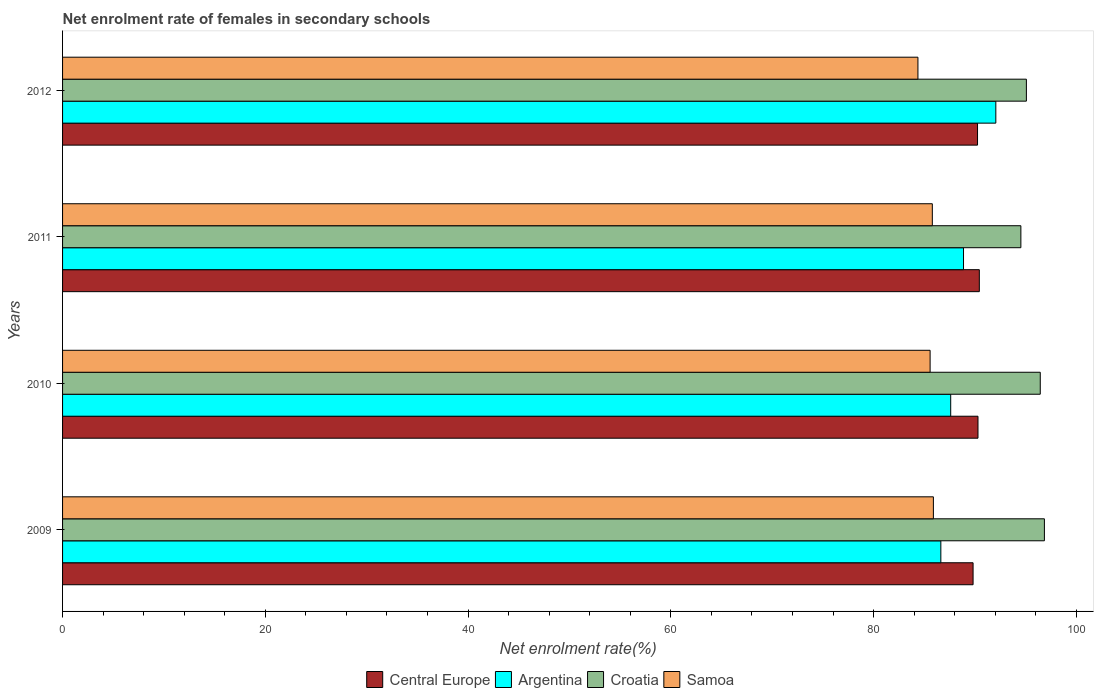How many different coloured bars are there?
Make the answer very short. 4. Are the number of bars per tick equal to the number of legend labels?
Keep it short and to the point. Yes. Are the number of bars on each tick of the Y-axis equal?
Offer a terse response. Yes. How many bars are there on the 2nd tick from the bottom?
Make the answer very short. 4. What is the label of the 1st group of bars from the top?
Keep it short and to the point. 2012. In how many cases, is the number of bars for a given year not equal to the number of legend labels?
Provide a succinct answer. 0. What is the net enrolment rate of females in secondary schools in Samoa in 2010?
Your answer should be compact. 85.58. Across all years, what is the maximum net enrolment rate of females in secondary schools in Argentina?
Make the answer very short. 92.06. Across all years, what is the minimum net enrolment rate of females in secondary schools in Central Europe?
Ensure brevity in your answer.  89.82. In which year was the net enrolment rate of females in secondary schools in Argentina maximum?
Offer a terse response. 2012. In which year was the net enrolment rate of females in secondary schools in Central Europe minimum?
Make the answer very short. 2009. What is the total net enrolment rate of females in secondary schools in Croatia in the graph?
Keep it short and to the point. 382.9. What is the difference between the net enrolment rate of females in secondary schools in Samoa in 2009 and that in 2011?
Provide a short and direct response. 0.11. What is the difference between the net enrolment rate of females in secondary schools in Samoa in 2010 and the net enrolment rate of females in secondary schools in Argentina in 2009?
Offer a very short reply. -1.06. What is the average net enrolment rate of females in secondary schools in Central Europe per year?
Your answer should be compact. 90.2. In the year 2011, what is the difference between the net enrolment rate of females in secondary schools in Samoa and net enrolment rate of females in secondary schools in Central Europe?
Provide a short and direct response. -4.64. In how many years, is the net enrolment rate of females in secondary schools in Samoa greater than 32 %?
Your answer should be compact. 4. What is the ratio of the net enrolment rate of females in secondary schools in Samoa in 2011 to that in 2012?
Your response must be concise. 1.02. Is the net enrolment rate of females in secondary schools in Central Europe in 2009 less than that in 2012?
Offer a very short reply. Yes. What is the difference between the highest and the second highest net enrolment rate of females in secondary schools in Croatia?
Make the answer very short. 0.41. What is the difference between the highest and the lowest net enrolment rate of females in secondary schools in Central Europe?
Your answer should be compact. 0.62. In how many years, is the net enrolment rate of females in secondary schools in Samoa greater than the average net enrolment rate of females in secondary schools in Samoa taken over all years?
Make the answer very short. 3. Is the sum of the net enrolment rate of females in secondary schools in Samoa in 2009 and 2012 greater than the maximum net enrolment rate of females in secondary schools in Croatia across all years?
Ensure brevity in your answer.  Yes. Is it the case that in every year, the sum of the net enrolment rate of females in secondary schools in Argentina and net enrolment rate of females in secondary schools in Central Europe is greater than the sum of net enrolment rate of females in secondary schools in Samoa and net enrolment rate of females in secondary schools in Croatia?
Your answer should be compact. No. What does the 1st bar from the top in 2012 represents?
Keep it short and to the point. Samoa. What does the 1st bar from the bottom in 2012 represents?
Your answer should be compact. Central Europe. Is it the case that in every year, the sum of the net enrolment rate of females in secondary schools in Croatia and net enrolment rate of females in secondary schools in Central Europe is greater than the net enrolment rate of females in secondary schools in Argentina?
Your response must be concise. Yes. How many years are there in the graph?
Make the answer very short. 4. What is the difference between two consecutive major ticks on the X-axis?
Your answer should be very brief. 20. Does the graph contain any zero values?
Make the answer very short. No. How many legend labels are there?
Your response must be concise. 4. How are the legend labels stacked?
Provide a short and direct response. Horizontal. What is the title of the graph?
Your response must be concise. Net enrolment rate of females in secondary schools. What is the label or title of the X-axis?
Your answer should be compact. Net enrolment rate(%). What is the label or title of the Y-axis?
Your answer should be compact. Years. What is the Net enrolment rate(%) in Central Europe in 2009?
Your answer should be compact. 89.82. What is the Net enrolment rate(%) in Argentina in 2009?
Provide a succinct answer. 86.64. What is the Net enrolment rate(%) of Croatia in 2009?
Provide a succinct answer. 96.85. What is the Net enrolment rate(%) of Samoa in 2009?
Keep it short and to the point. 85.9. What is the Net enrolment rate(%) of Central Europe in 2010?
Your answer should be very brief. 90.3. What is the Net enrolment rate(%) of Argentina in 2010?
Your response must be concise. 87.61. What is the Net enrolment rate(%) of Croatia in 2010?
Your answer should be very brief. 96.44. What is the Net enrolment rate(%) of Samoa in 2010?
Offer a terse response. 85.58. What is the Net enrolment rate(%) of Central Europe in 2011?
Your response must be concise. 90.43. What is the Net enrolment rate(%) of Argentina in 2011?
Your answer should be compact. 88.87. What is the Net enrolment rate(%) of Croatia in 2011?
Provide a succinct answer. 94.53. What is the Net enrolment rate(%) in Samoa in 2011?
Give a very brief answer. 85.8. What is the Net enrolment rate(%) in Central Europe in 2012?
Your answer should be very brief. 90.26. What is the Net enrolment rate(%) in Argentina in 2012?
Provide a short and direct response. 92.06. What is the Net enrolment rate(%) of Croatia in 2012?
Offer a terse response. 95.08. What is the Net enrolment rate(%) in Samoa in 2012?
Ensure brevity in your answer.  84.38. Across all years, what is the maximum Net enrolment rate(%) of Central Europe?
Your answer should be very brief. 90.43. Across all years, what is the maximum Net enrolment rate(%) of Argentina?
Keep it short and to the point. 92.06. Across all years, what is the maximum Net enrolment rate(%) of Croatia?
Provide a succinct answer. 96.85. Across all years, what is the maximum Net enrolment rate(%) in Samoa?
Provide a short and direct response. 85.9. Across all years, what is the minimum Net enrolment rate(%) of Central Europe?
Provide a short and direct response. 89.82. Across all years, what is the minimum Net enrolment rate(%) of Argentina?
Offer a terse response. 86.64. Across all years, what is the minimum Net enrolment rate(%) of Croatia?
Your answer should be very brief. 94.53. Across all years, what is the minimum Net enrolment rate(%) of Samoa?
Provide a short and direct response. 84.38. What is the total Net enrolment rate(%) of Central Europe in the graph?
Ensure brevity in your answer.  360.81. What is the total Net enrolment rate(%) in Argentina in the graph?
Offer a terse response. 355.18. What is the total Net enrolment rate(%) of Croatia in the graph?
Provide a short and direct response. 382.9. What is the total Net enrolment rate(%) in Samoa in the graph?
Provide a short and direct response. 341.65. What is the difference between the Net enrolment rate(%) of Central Europe in 2009 and that in 2010?
Keep it short and to the point. -0.48. What is the difference between the Net enrolment rate(%) in Argentina in 2009 and that in 2010?
Ensure brevity in your answer.  -0.97. What is the difference between the Net enrolment rate(%) in Croatia in 2009 and that in 2010?
Provide a short and direct response. 0.41. What is the difference between the Net enrolment rate(%) of Samoa in 2009 and that in 2010?
Your response must be concise. 0.32. What is the difference between the Net enrolment rate(%) of Central Europe in 2009 and that in 2011?
Give a very brief answer. -0.62. What is the difference between the Net enrolment rate(%) of Argentina in 2009 and that in 2011?
Provide a short and direct response. -2.24. What is the difference between the Net enrolment rate(%) in Croatia in 2009 and that in 2011?
Your answer should be very brief. 2.32. What is the difference between the Net enrolment rate(%) of Samoa in 2009 and that in 2011?
Offer a very short reply. 0.11. What is the difference between the Net enrolment rate(%) in Central Europe in 2009 and that in 2012?
Your response must be concise. -0.44. What is the difference between the Net enrolment rate(%) of Argentina in 2009 and that in 2012?
Your answer should be very brief. -5.42. What is the difference between the Net enrolment rate(%) of Croatia in 2009 and that in 2012?
Provide a succinct answer. 1.78. What is the difference between the Net enrolment rate(%) of Samoa in 2009 and that in 2012?
Give a very brief answer. 1.52. What is the difference between the Net enrolment rate(%) of Central Europe in 2010 and that in 2011?
Offer a terse response. -0.13. What is the difference between the Net enrolment rate(%) in Argentina in 2010 and that in 2011?
Offer a terse response. -1.26. What is the difference between the Net enrolment rate(%) of Croatia in 2010 and that in 2011?
Ensure brevity in your answer.  1.91. What is the difference between the Net enrolment rate(%) of Samoa in 2010 and that in 2011?
Provide a short and direct response. -0.22. What is the difference between the Net enrolment rate(%) of Central Europe in 2010 and that in 2012?
Give a very brief answer. 0.04. What is the difference between the Net enrolment rate(%) of Argentina in 2010 and that in 2012?
Ensure brevity in your answer.  -4.45. What is the difference between the Net enrolment rate(%) in Croatia in 2010 and that in 2012?
Give a very brief answer. 1.37. What is the difference between the Net enrolment rate(%) of Samoa in 2010 and that in 2012?
Offer a very short reply. 1.2. What is the difference between the Net enrolment rate(%) in Central Europe in 2011 and that in 2012?
Keep it short and to the point. 0.18. What is the difference between the Net enrolment rate(%) of Argentina in 2011 and that in 2012?
Provide a short and direct response. -3.19. What is the difference between the Net enrolment rate(%) in Croatia in 2011 and that in 2012?
Keep it short and to the point. -0.54. What is the difference between the Net enrolment rate(%) in Samoa in 2011 and that in 2012?
Offer a very short reply. 1.42. What is the difference between the Net enrolment rate(%) in Central Europe in 2009 and the Net enrolment rate(%) in Argentina in 2010?
Provide a short and direct response. 2.21. What is the difference between the Net enrolment rate(%) of Central Europe in 2009 and the Net enrolment rate(%) of Croatia in 2010?
Your response must be concise. -6.63. What is the difference between the Net enrolment rate(%) in Central Europe in 2009 and the Net enrolment rate(%) in Samoa in 2010?
Provide a short and direct response. 4.24. What is the difference between the Net enrolment rate(%) in Argentina in 2009 and the Net enrolment rate(%) in Croatia in 2010?
Your answer should be very brief. -9.81. What is the difference between the Net enrolment rate(%) of Argentina in 2009 and the Net enrolment rate(%) of Samoa in 2010?
Your answer should be compact. 1.06. What is the difference between the Net enrolment rate(%) in Croatia in 2009 and the Net enrolment rate(%) in Samoa in 2010?
Your response must be concise. 11.27. What is the difference between the Net enrolment rate(%) in Central Europe in 2009 and the Net enrolment rate(%) in Argentina in 2011?
Your response must be concise. 0.94. What is the difference between the Net enrolment rate(%) in Central Europe in 2009 and the Net enrolment rate(%) in Croatia in 2011?
Your response must be concise. -4.71. What is the difference between the Net enrolment rate(%) of Central Europe in 2009 and the Net enrolment rate(%) of Samoa in 2011?
Offer a very short reply. 4.02. What is the difference between the Net enrolment rate(%) in Argentina in 2009 and the Net enrolment rate(%) in Croatia in 2011?
Offer a terse response. -7.9. What is the difference between the Net enrolment rate(%) in Argentina in 2009 and the Net enrolment rate(%) in Samoa in 2011?
Offer a very short reply. 0.84. What is the difference between the Net enrolment rate(%) in Croatia in 2009 and the Net enrolment rate(%) in Samoa in 2011?
Provide a succinct answer. 11.05. What is the difference between the Net enrolment rate(%) of Central Europe in 2009 and the Net enrolment rate(%) of Argentina in 2012?
Keep it short and to the point. -2.24. What is the difference between the Net enrolment rate(%) in Central Europe in 2009 and the Net enrolment rate(%) in Croatia in 2012?
Give a very brief answer. -5.26. What is the difference between the Net enrolment rate(%) in Central Europe in 2009 and the Net enrolment rate(%) in Samoa in 2012?
Ensure brevity in your answer.  5.44. What is the difference between the Net enrolment rate(%) in Argentina in 2009 and the Net enrolment rate(%) in Croatia in 2012?
Provide a succinct answer. -8.44. What is the difference between the Net enrolment rate(%) of Argentina in 2009 and the Net enrolment rate(%) of Samoa in 2012?
Offer a very short reply. 2.26. What is the difference between the Net enrolment rate(%) of Croatia in 2009 and the Net enrolment rate(%) of Samoa in 2012?
Ensure brevity in your answer.  12.47. What is the difference between the Net enrolment rate(%) in Central Europe in 2010 and the Net enrolment rate(%) in Argentina in 2011?
Ensure brevity in your answer.  1.43. What is the difference between the Net enrolment rate(%) in Central Europe in 2010 and the Net enrolment rate(%) in Croatia in 2011?
Make the answer very short. -4.23. What is the difference between the Net enrolment rate(%) in Central Europe in 2010 and the Net enrolment rate(%) in Samoa in 2011?
Your response must be concise. 4.5. What is the difference between the Net enrolment rate(%) of Argentina in 2010 and the Net enrolment rate(%) of Croatia in 2011?
Your response must be concise. -6.92. What is the difference between the Net enrolment rate(%) of Argentina in 2010 and the Net enrolment rate(%) of Samoa in 2011?
Keep it short and to the point. 1.81. What is the difference between the Net enrolment rate(%) of Croatia in 2010 and the Net enrolment rate(%) of Samoa in 2011?
Give a very brief answer. 10.65. What is the difference between the Net enrolment rate(%) of Central Europe in 2010 and the Net enrolment rate(%) of Argentina in 2012?
Offer a terse response. -1.76. What is the difference between the Net enrolment rate(%) of Central Europe in 2010 and the Net enrolment rate(%) of Croatia in 2012?
Your answer should be very brief. -4.78. What is the difference between the Net enrolment rate(%) in Central Europe in 2010 and the Net enrolment rate(%) in Samoa in 2012?
Your answer should be compact. 5.92. What is the difference between the Net enrolment rate(%) of Argentina in 2010 and the Net enrolment rate(%) of Croatia in 2012?
Ensure brevity in your answer.  -7.47. What is the difference between the Net enrolment rate(%) in Argentina in 2010 and the Net enrolment rate(%) in Samoa in 2012?
Give a very brief answer. 3.23. What is the difference between the Net enrolment rate(%) of Croatia in 2010 and the Net enrolment rate(%) of Samoa in 2012?
Give a very brief answer. 12.07. What is the difference between the Net enrolment rate(%) in Central Europe in 2011 and the Net enrolment rate(%) in Argentina in 2012?
Your answer should be very brief. -1.63. What is the difference between the Net enrolment rate(%) in Central Europe in 2011 and the Net enrolment rate(%) in Croatia in 2012?
Make the answer very short. -4.64. What is the difference between the Net enrolment rate(%) in Central Europe in 2011 and the Net enrolment rate(%) in Samoa in 2012?
Provide a succinct answer. 6.06. What is the difference between the Net enrolment rate(%) in Argentina in 2011 and the Net enrolment rate(%) in Croatia in 2012?
Provide a short and direct response. -6.2. What is the difference between the Net enrolment rate(%) in Argentina in 2011 and the Net enrolment rate(%) in Samoa in 2012?
Give a very brief answer. 4.5. What is the difference between the Net enrolment rate(%) in Croatia in 2011 and the Net enrolment rate(%) in Samoa in 2012?
Offer a terse response. 10.15. What is the average Net enrolment rate(%) in Central Europe per year?
Keep it short and to the point. 90.2. What is the average Net enrolment rate(%) in Argentina per year?
Ensure brevity in your answer.  88.79. What is the average Net enrolment rate(%) in Croatia per year?
Provide a short and direct response. 95.73. What is the average Net enrolment rate(%) of Samoa per year?
Offer a very short reply. 85.41. In the year 2009, what is the difference between the Net enrolment rate(%) in Central Europe and Net enrolment rate(%) in Argentina?
Provide a short and direct response. 3.18. In the year 2009, what is the difference between the Net enrolment rate(%) in Central Europe and Net enrolment rate(%) in Croatia?
Your answer should be compact. -7.03. In the year 2009, what is the difference between the Net enrolment rate(%) in Central Europe and Net enrolment rate(%) in Samoa?
Make the answer very short. 3.92. In the year 2009, what is the difference between the Net enrolment rate(%) in Argentina and Net enrolment rate(%) in Croatia?
Provide a short and direct response. -10.22. In the year 2009, what is the difference between the Net enrolment rate(%) in Argentina and Net enrolment rate(%) in Samoa?
Make the answer very short. 0.73. In the year 2009, what is the difference between the Net enrolment rate(%) of Croatia and Net enrolment rate(%) of Samoa?
Give a very brief answer. 10.95. In the year 2010, what is the difference between the Net enrolment rate(%) in Central Europe and Net enrolment rate(%) in Argentina?
Provide a short and direct response. 2.69. In the year 2010, what is the difference between the Net enrolment rate(%) of Central Europe and Net enrolment rate(%) of Croatia?
Give a very brief answer. -6.14. In the year 2010, what is the difference between the Net enrolment rate(%) in Central Europe and Net enrolment rate(%) in Samoa?
Provide a short and direct response. 4.72. In the year 2010, what is the difference between the Net enrolment rate(%) of Argentina and Net enrolment rate(%) of Croatia?
Provide a succinct answer. -8.84. In the year 2010, what is the difference between the Net enrolment rate(%) in Argentina and Net enrolment rate(%) in Samoa?
Ensure brevity in your answer.  2.03. In the year 2010, what is the difference between the Net enrolment rate(%) of Croatia and Net enrolment rate(%) of Samoa?
Give a very brief answer. 10.87. In the year 2011, what is the difference between the Net enrolment rate(%) in Central Europe and Net enrolment rate(%) in Argentina?
Your answer should be compact. 1.56. In the year 2011, what is the difference between the Net enrolment rate(%) in Central Europe and Net enrolment rate(%) in Croatia?
Offer a terse response. -4.1. In the year 2011, what is the difference between the Net enrolment rate(%) of Central Europe and Net enrolment rate(%) of Samoa?
Your response must be concise. 4.64. In the year 2011, what is the difference between the Net enrolment rate(%) in Argentina and Net enrolment rate(%) in Croatia?
Provide a succinct answer. -5.66. In the year 2011, what is the difference between the Net enrolment rate(%) in Argentina and Net enrolment rate(%) in Samoa?
Ensure brevity in your answer.  3.08. In the year 2011, what is the difference between the Net enrolment rate(%) of Croatia and Net enrolment rate(%) of Samoa?
Offer a very short reply. 8.73. In the year 2012, what is the difference between the Net enrolment rate(%) in Central Europe and Net enrolment rate(%) in Argentina?
Make the answer very short. -1.8. In the year 2012, what is the difference between the Net enrolment rate(%) of Central Europe and Net enrolment rate(%) of Croatia?
Your answer should be compact. -4.82. In the year 2012, what is the difference between the Net enrolment rate(%) of Central Europe and Net enrolment rate(%) of Samoa?
Make the answer very short. 5.88. In the year 2012, what is the difference between the Net enrolment rate(%) of Argentina and Net enrolment rate(%) of Croatia?
Offer a very short reply. -3.02. In the year 2012, what is the difference between the Net enrolment rate(%) of Argentina and Net enrolment rate(%) of Samoa?
Offer a very short reply. 7.68. In the year 2012, what is the difference between the Net enrolment rate(%) of Croatia and Net enrolment rate(%) of Samoa?
Your answer should be very brief. 10.7. What is the ratio of the Net enrolment rate(%) of Argentina in 2009 to that in 2010?
Give a very brief answer. 0.99. What is the ratio of the Net enrolment rate(%) of Samoa in 2009 to that in 2010?
Give a very brief answer. 1. What is the ratio of the Net enrolment rate(%) of Argentina in 2009 to that in 2011?
Provide a succinct answer. 0.97. What is the ratio of the Net enrolment rate(%) of Croatia in 2009 to that in 2011?
Your answer should be compact. 1.02. What is the ratio of the Net enrolment rate(%) of Samoa in 2009 to that in 2011?
Ensure brevity in your answer.  1. What is the ratio of the Net enrolment rate(%) in Central Europe in 2009 to that in 2012?
Your response must be concise. 1. What is the ratio of the Net enrolment rate(%) in Argentina in 2009 to that in 2012?
Provide a short and direct response. 0.94. What is the ratio of the Net enrolment rate(%) of Croatia in 2009 to that in 2012?
Your answer should be compact. 1.02. What is the ratio of the Net enrolment rate(%) in Samoa in 2009 to that in 2012?
Offer a very short reply. 1.02. What is the ratio of the Net enrolment rate(%) in Argentina in 2010 to that in 2011?
Ensure brevity in your answer.  0.99. What is the ratio of the Net enrolment rate(%) of Croatia in 2010 to that in 2011?
Provide a short and direct response. 1.02. What is the ratio of the Net enrolment rate(%) of Central Europe in 2010 to that in 2012?
Give a very brief answer. 1. What is the ratio of the Net enrolment rate(%) of Argentina in 2010 to that in 2012?
Your answer should be very brief. 0.95. What is the ratio of the Net enrolment rate(%) of Croatia in 2010 to that in 2012?
Your response must be concise. 1.01. What is the ratio of the Net enrolment rate(%) of Samoa in 2010 to that in 2012?
Offer a terse response. 1.01. What is the ratio of the Net enrolment rate(%) of Argentina in 2011 to that in 2012?
Provide a succinct answer. 0.97. What is the ratio of the Net enrolment rate(%) in Samoa in 2011 to that in 2012?
Your answer should be compact. 1.02. What is the difference between the highest and the second highest Net enrolment rate(%) of Central Europe?
Offer a very short reply. 0.13. What is the difference between the highest and the second highest Net enrolment rate(%) of Argentina?
Ensure brevity in your answer.  3.19. What is the difference between the highest and the second highest Net enrolment rate(%) of Croatia?
Provide a succinct answer. 0.41. What is the difference between the highest and the second highest Net enrolment rate(%) of Samoa?
Offer a terse response. 0.11. What is the difference between the highest and the lowest Net enrolment rate(%) of Central Europe?
Provide a short and direct response. 0.62. What is the difference between the highest and the lowest Net enrolment rate(%) in Argentina?
Your response must be concise. 5.42. What is the difference between the highest and the lowest Net enrolment rate(%) of Croatia?
Offer a terse response. 2.32. What is the difference between the highest and the lowest Net enrolment rate(%) in Samoa?
Your response must be concise. 1.52. 